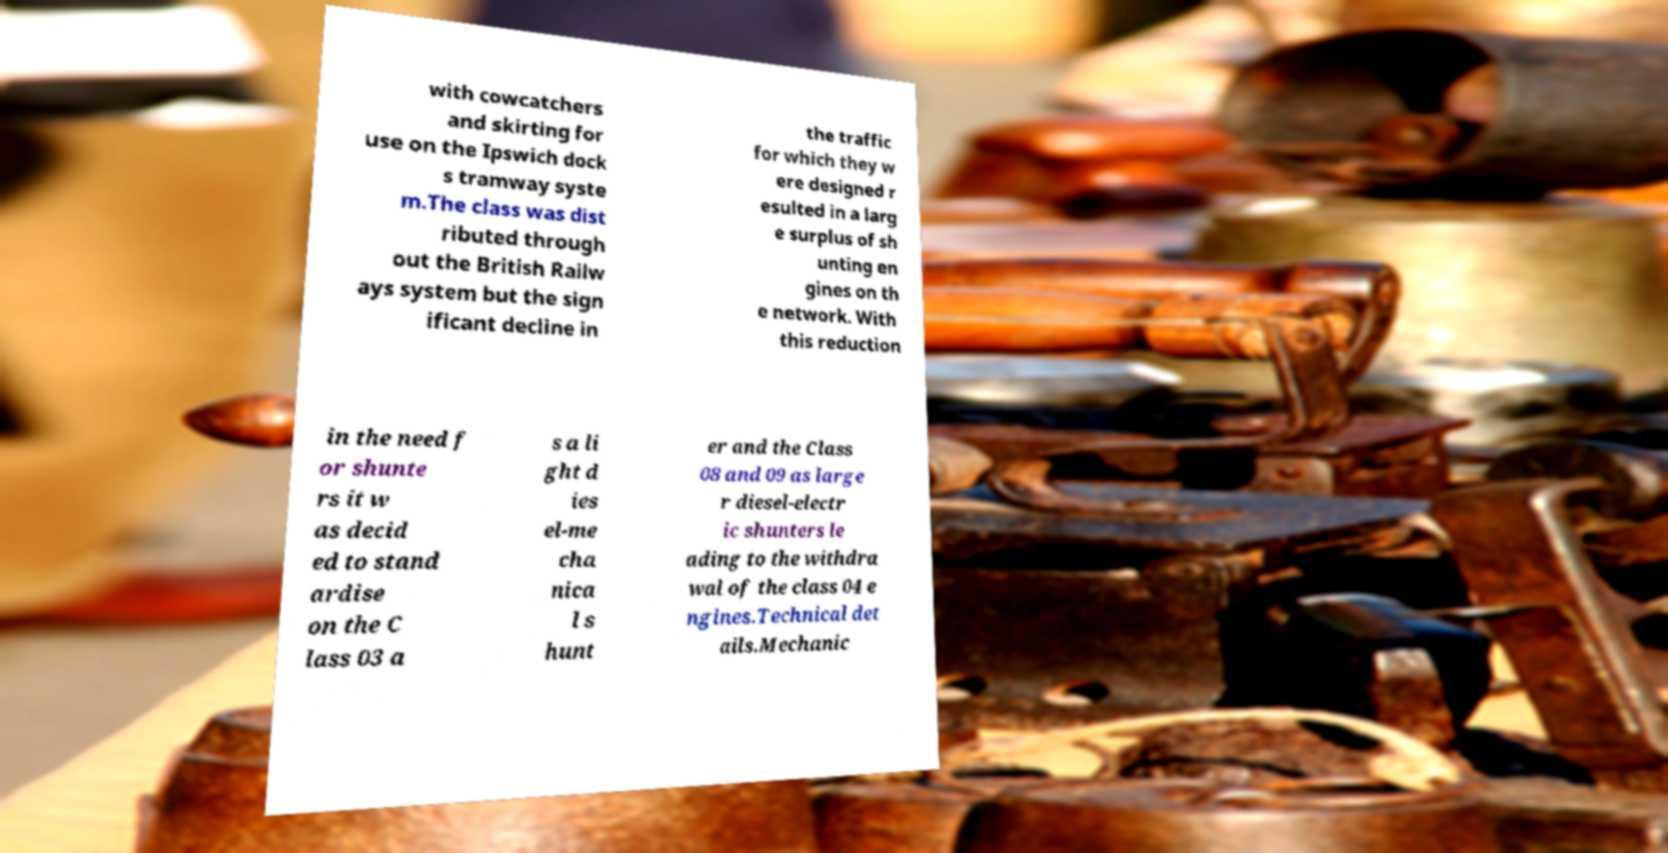What messages or text are displayed in this image? I need them in a readable, typed format. with cowcatchers and skirting for use on the Ipswich dock s tramway syste m.The class was dist ributed through out the British Railw ays system but the sign ificant decline in the traffic for which they w ere designed r esulted in a larg e surplus of sh unting en gines on th e network. With this reduction in the need f or shunte rs it w as decid ed to stand ardise on the C lass 03 a s a li ght d ies el-me cha nica l s hunt er and the Class 08 and 09 as large r diesel-electr ic shunters le ading to the withdra wal of the class 04 e ngines.Technical det ails.Mechanic 